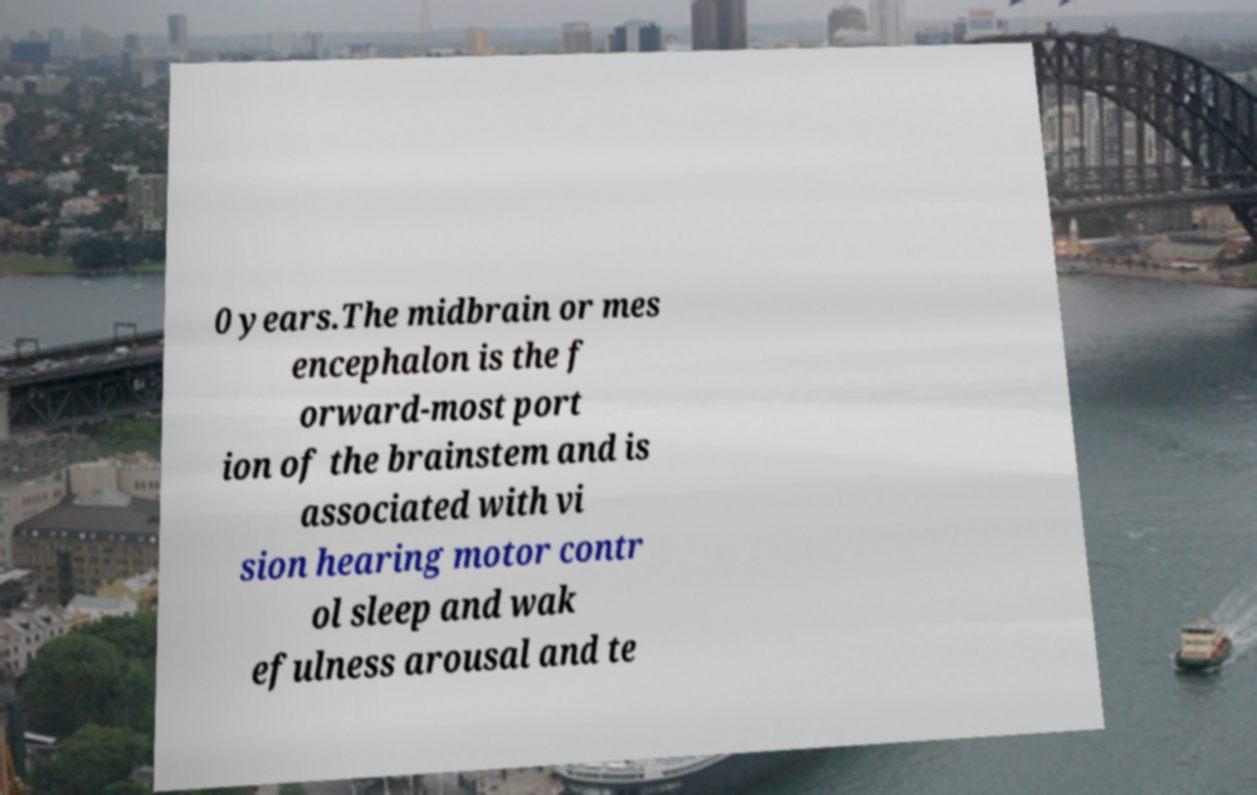What messages or text are displayed in this image? I need them in a readable, typed format. 0 years.The midbrain or mes encephalon is the f orward-most port ion of the brainstem and is associated with vi sion hearing motor contr ol sleep and wak efulness arousal and te 